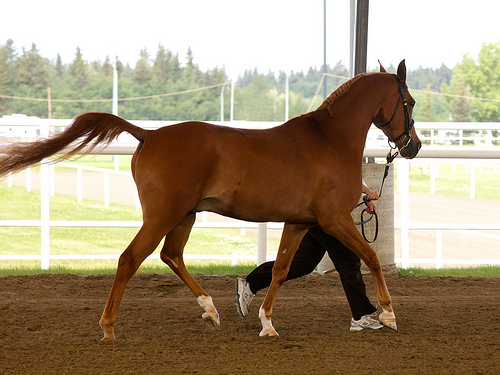<image>
Is the horse in front of the man? Yes. The horse is positioned in front of the man, appearing closer to the camera viewpoint. 